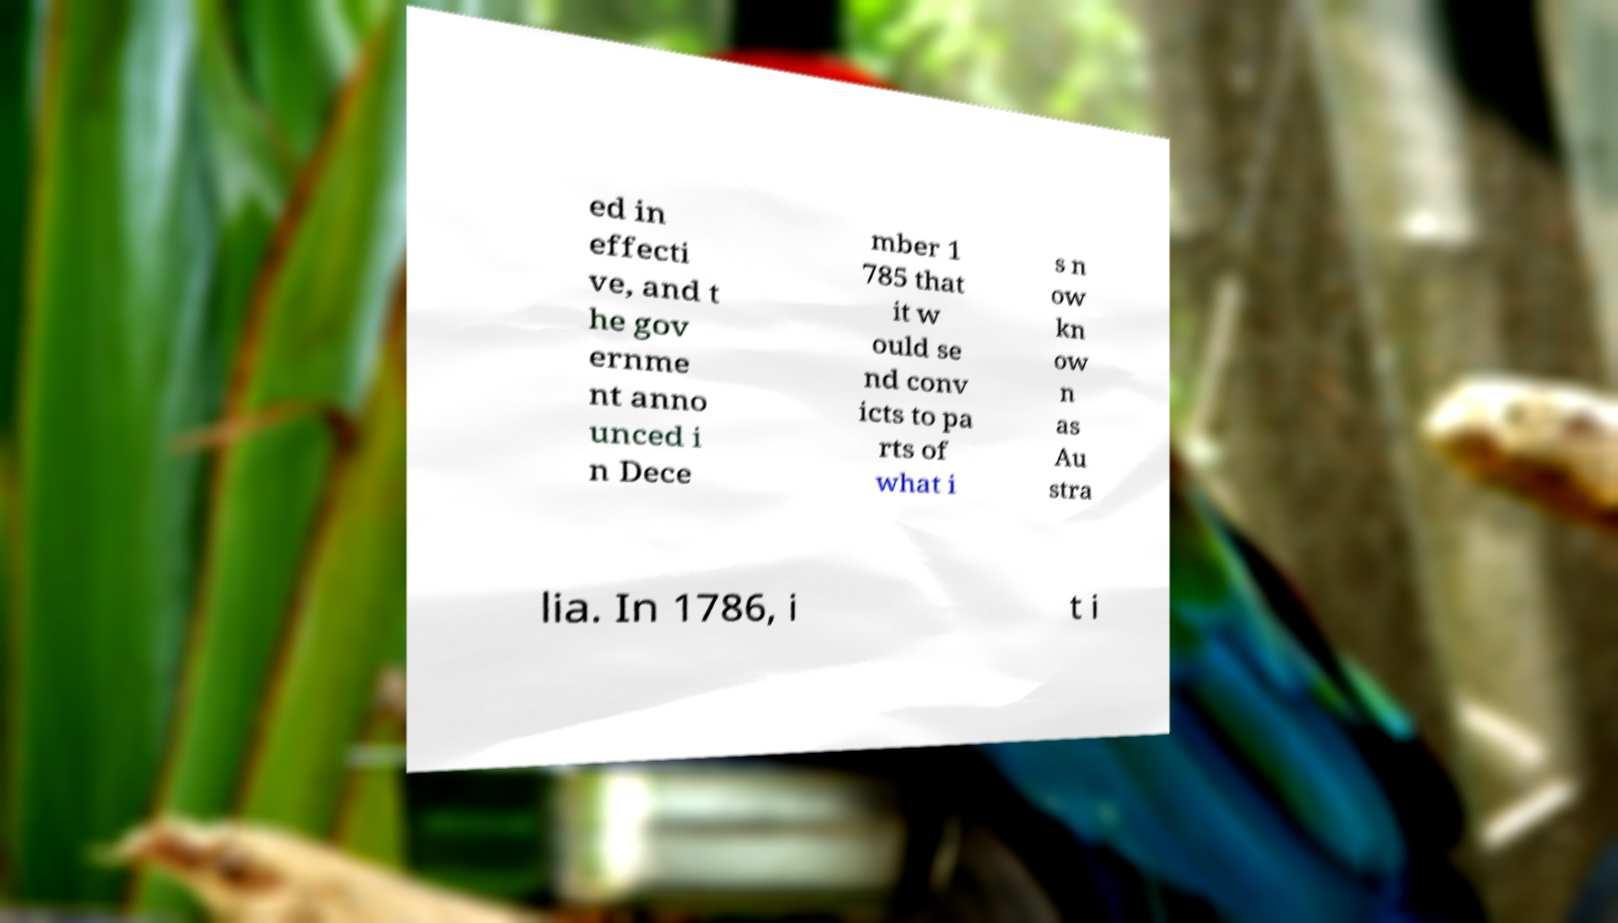Can you read and provide the text displayed in the image?This photo seems to have some interesting text. Can you extract and type it out for me? ed in effecti ve, and t he gov ernme nt anno unced i n Dece mber 1 785 that it w ould se nd conv icts to pa rts of what i s n ow kn ow n as Au stra lia. In 1786, i t i 